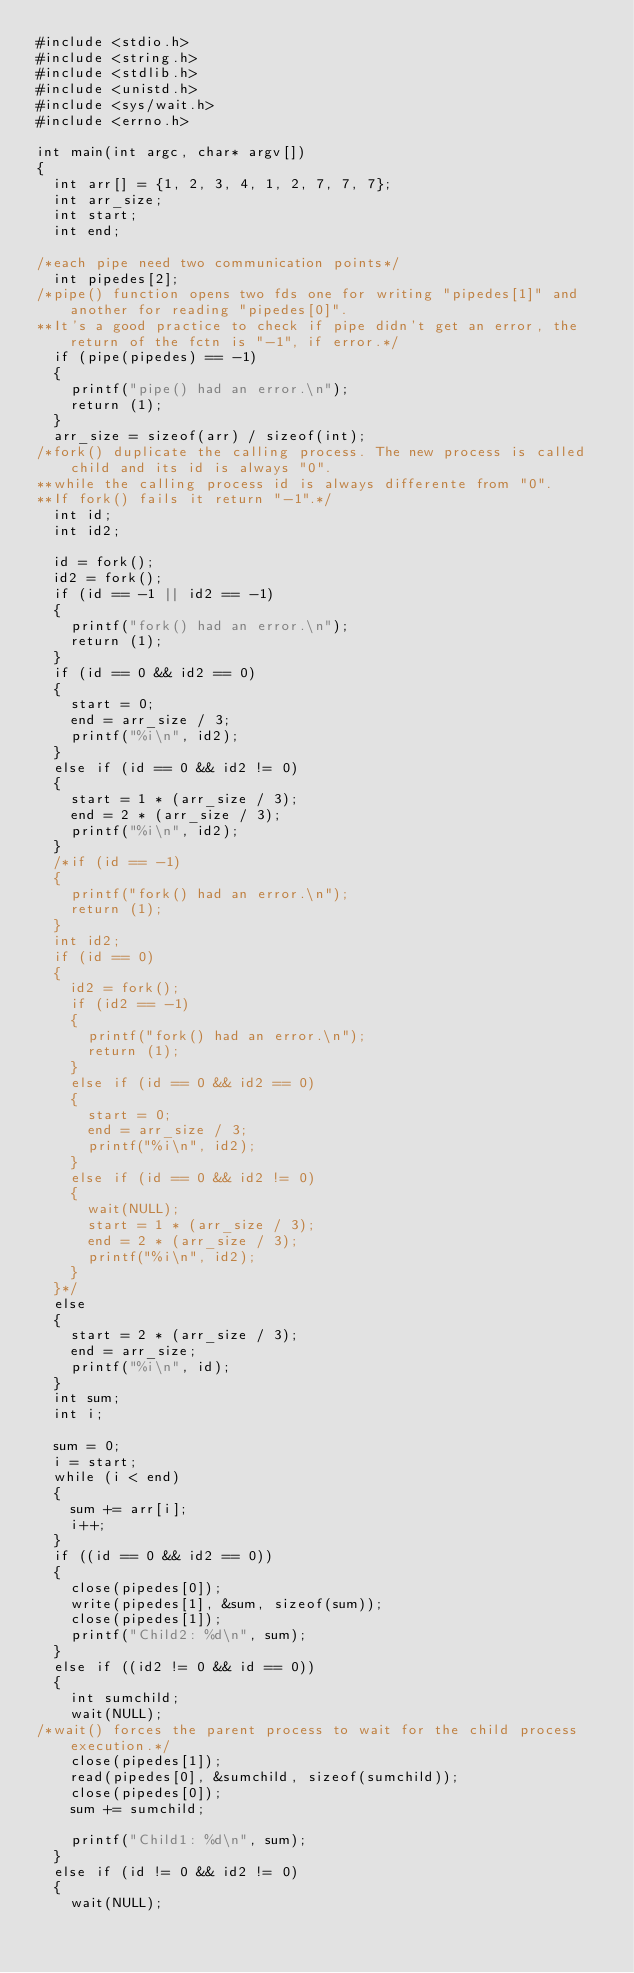<code> <loc_0><loc_0><loc_500><loc_500><_C_>#include <stdio.h>
#include <string.h>
#include <stdlib.h>
#include <unistd.h>
#include <sys/wait.h>
#include <errno.h>

int	main(int argc, char* argv[])
{
	int arr[] = {1, 2, 3, 4, 1, 2, 7, 7, 7};
	int	arr_size;
	int	start;
	int	end;
	
/*each pipe need two communication points*/
	int pipedes[2];
/*pipe() function opens two fds one for writing "pipedes[1]" and another for reading "pipedes[0]".
**It's a good practice to check if pipe didn't get an error, the return of the fctn is "-1", if error.*/
	if (pipe(pipedes) == -1)
	{
		printf("pipe() had an error.\n");
		return (1);
	}
	arr_size = sizeof(arr) / sizeof(int);
/*fork() duplicate the calling process. The new process is called child and its id is always "0".
**while the calling process id is always differente from "0".
**If fork() fails it return "-1".*/
	int	id;
	int	id2;

	id = fork();
	id2 = fork();
	if (id == -1 || id2 == -1)
	{
		printf("fork() had an error.\n");
		return (1);
	}
	if (id == 0 && id2 == 0)
	{
		start = 0;
		end = arr_size / 3;
		printf("%i\n", id2);
	}
	else if (id == 0 && id2 != 0)
	{
		start = 1 * (arr_size / 3);
		end = 2 * (arr_size / 3);
		printf("%i\n", id2);
	}
	/*if (id == -1)
	{
		printf("fork() had an error.\n");
		return (1);
	}
	int id2;
	if (id == 0)
	{
		id2 = fork();
		if (id2 == -1)
		{
			printf("fork() had an error.\n");
			return (1);
		}
		else if (id == 0 && id2 == 0)
		{
			start = 0;
			end = arr_size / 3;
			printf("%i\n", id2);
		}
		else if (id == 0 && id2 != 0)
		{
			wait(NULL);
			start = 1 * (arr_size / 3);
			end = 2 * (arr_size / 3);
			printf("%i\n", id2);
		}
	}*/
	else
	{
		start = 2 * (arr_size / 3);
		end = arr_size;
		printf("%i\n", id);
	}
	int	sum;
	int	i;

	sum = 0;
	i = start;
	while (i < end)
	{
		sum += arr[i];
		i++;
	}
	if ((id == 0 && id2 == 0))
	{
		close(pipedes[0]);
		write(pipedes[1], &sum, sizeof(sum));
		close(pipedes[1]);
		printf("Child2: %d\n", sum);
	}
	else if ((id2 != 0 && id == 0))
	{
		int	sumchild;
		wait(NULL);
/*wait() forces the parent process to wait for the child process execution.*/	
		close(pipedes[1]);
		read(pipedes[0], &sumchild, sizeof(sumchild));
		close(pipedes[0]);
		sum += sumchild;
		
		printf("Child1: %d\n", sum);
	}
	else if (id != 0 && id2 != 0)
	{
		wait(NULL);</code> 